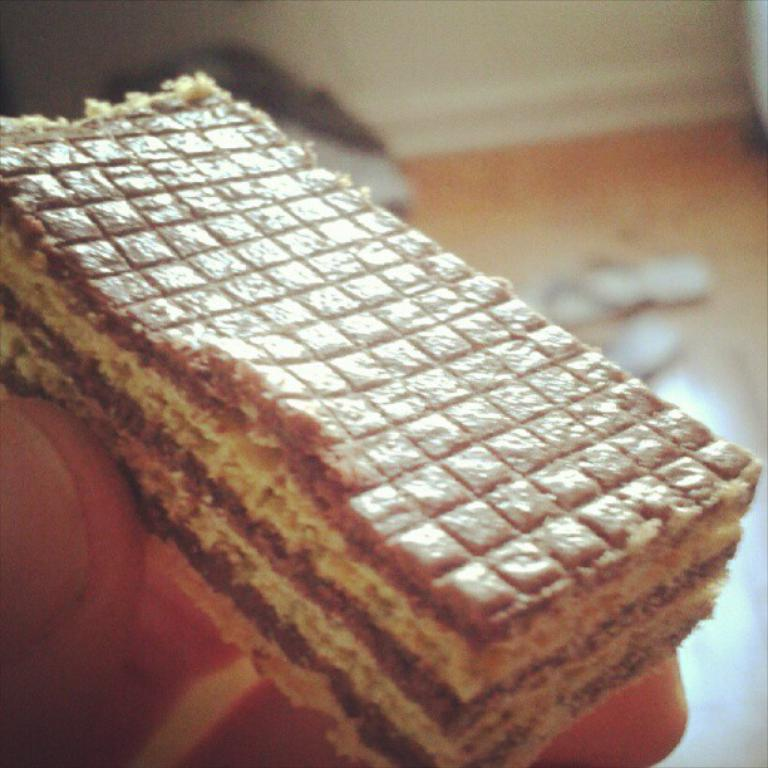What is the person in the image holding? The person is holding food in their hand. Can you describe the background of the image? The background of the image is blurry. What else can be seen in the background of the image? There is footwear visible in the background. What type of pear is being stored in the can in the cellar in the image? There is no pear, can, or cellar present in the image. 